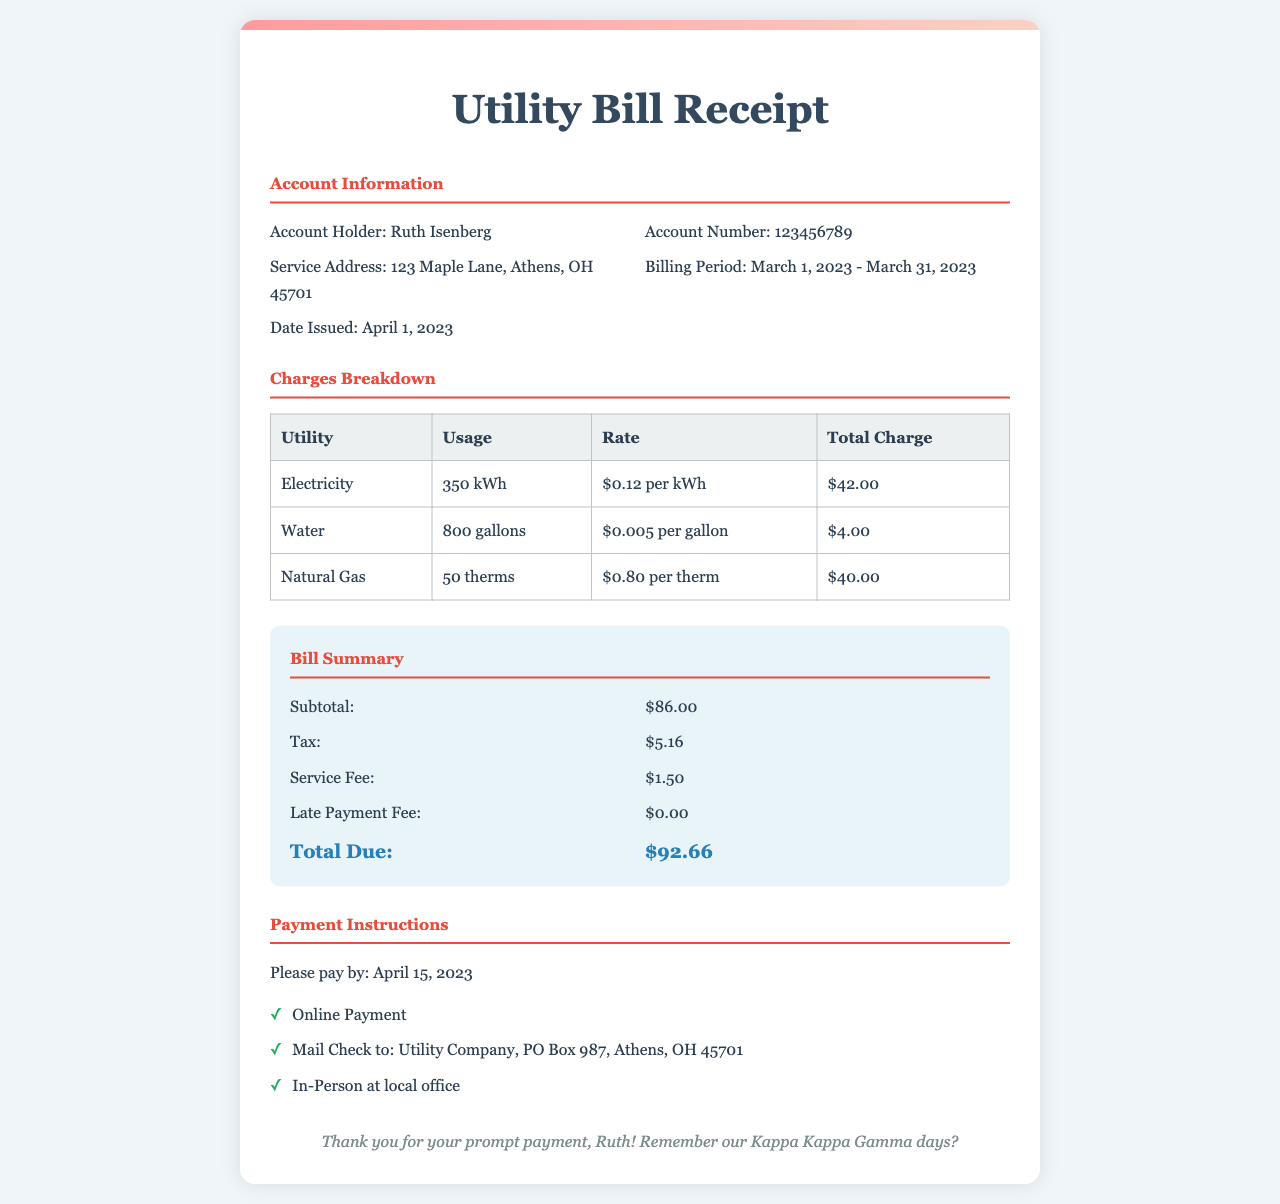what is the account holder's name? The account holder's name is mentioned in the account information section of the document as Ruth Isenberg.
Answer: Ruth Isenberg what is the billing period? The billing period is specified in the account information section of the document as March 1, 2023 - March 31, 2023.
Answer: March 1, 2023 - March 31, 2023 how much was charged for natural gas? The charge for natural gas is detailed in the charges breakdown section, which states that the total charge is $40.00.
Answer: $40.00 what is the total due amount? The total due amount is found in the bill summary section and sums up all charges, which equals $92.66.
Answer: $92.66 how many gallons of water were used? The document specifies that the usage of water during the billing period was 800 gallons in the charges breakdown.
Answer: 800 gallons what is the late payment fee? The late payment fee is listed in the bill summary section and is indicated as $0.00.
Answer: $0.00 when was the bill issued? The date issued is provided in the account information section, which states that the bill was issued on April 1, 2023.
Answer: April 1, 2023 what is the charge per kWh for electricity? The charge per kWh for electricity is mentioned in the charges breakdown section as $0.12 per kWh.
Answer: $0.12 per kWh how can payments be made? The payment instructions section lists three methods: Online Payment, Mail Check, and In-Person at local office.
Answer: Online Payment, Mail Check, In-Person at local office 